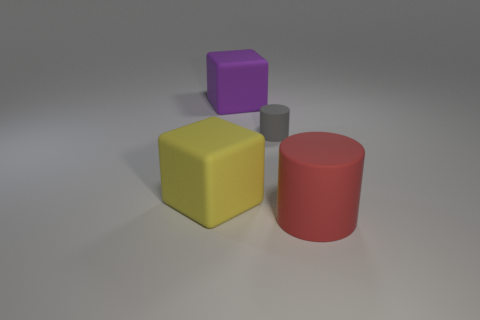Add 1 rubber cubes. How many objects exist? 5 Subtract 1 yellow cubes. How many objects are left? 3 Subtract all tiny matte cylinders. Subtract all red matte things. How many objects are left? 2 Add 3 rubber objects. How many rubber objects are left? 7 Add 2 red matte things. How many red matte things exist? 3 